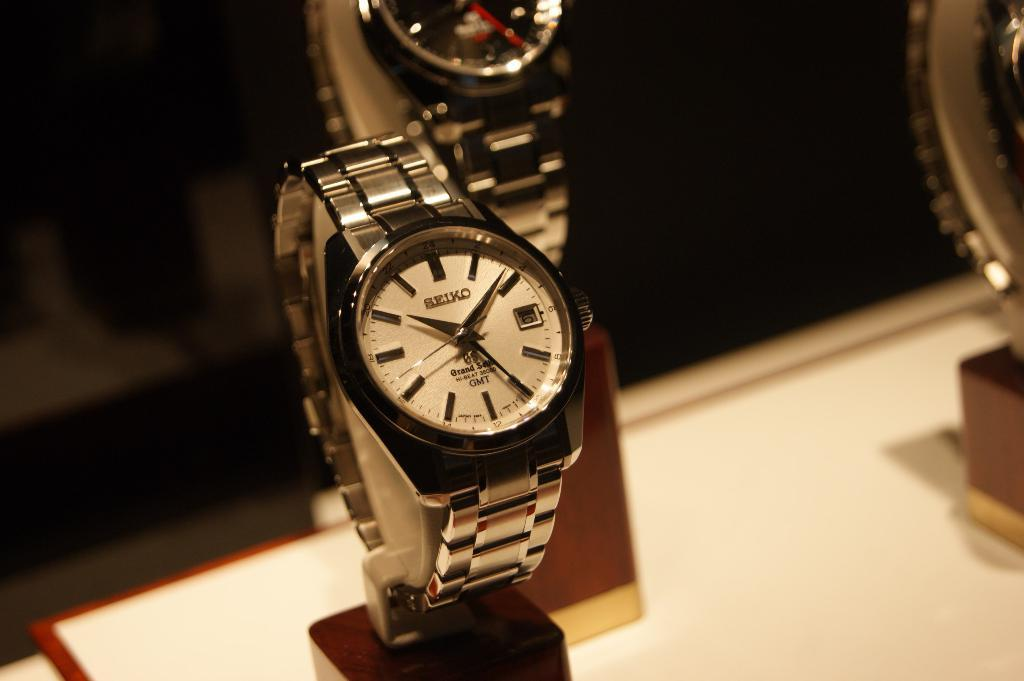What type of objects are featured in the image? There are wrist watches in the image. How are the wrist watches displayed in the image? The wrist watches are placed on stands. How many houses can be seen in the image? There are no houses present in the image; it features wrist watches on stands. What type of animal is visible in the image? There is no animal, such as a rabbit, present in the image. 